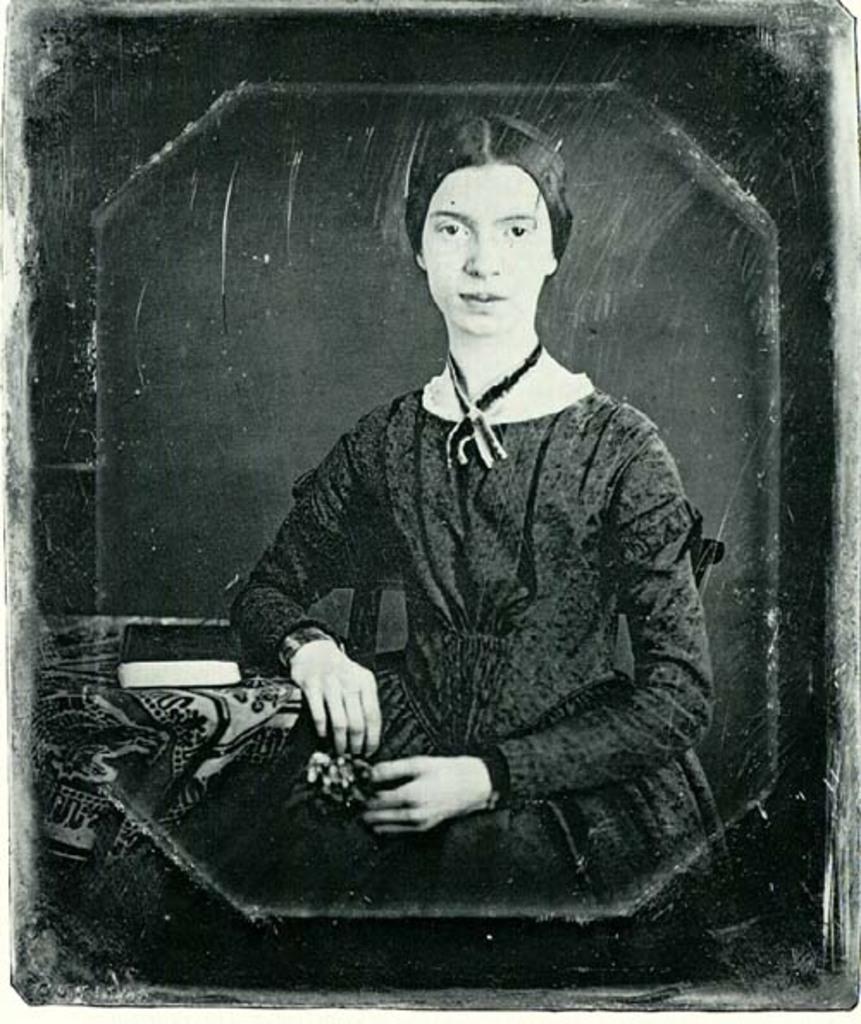Please provide a concise description of this image. This is a black and white image of a lady sitting. Near to her there is a table. On the table there is a book. 